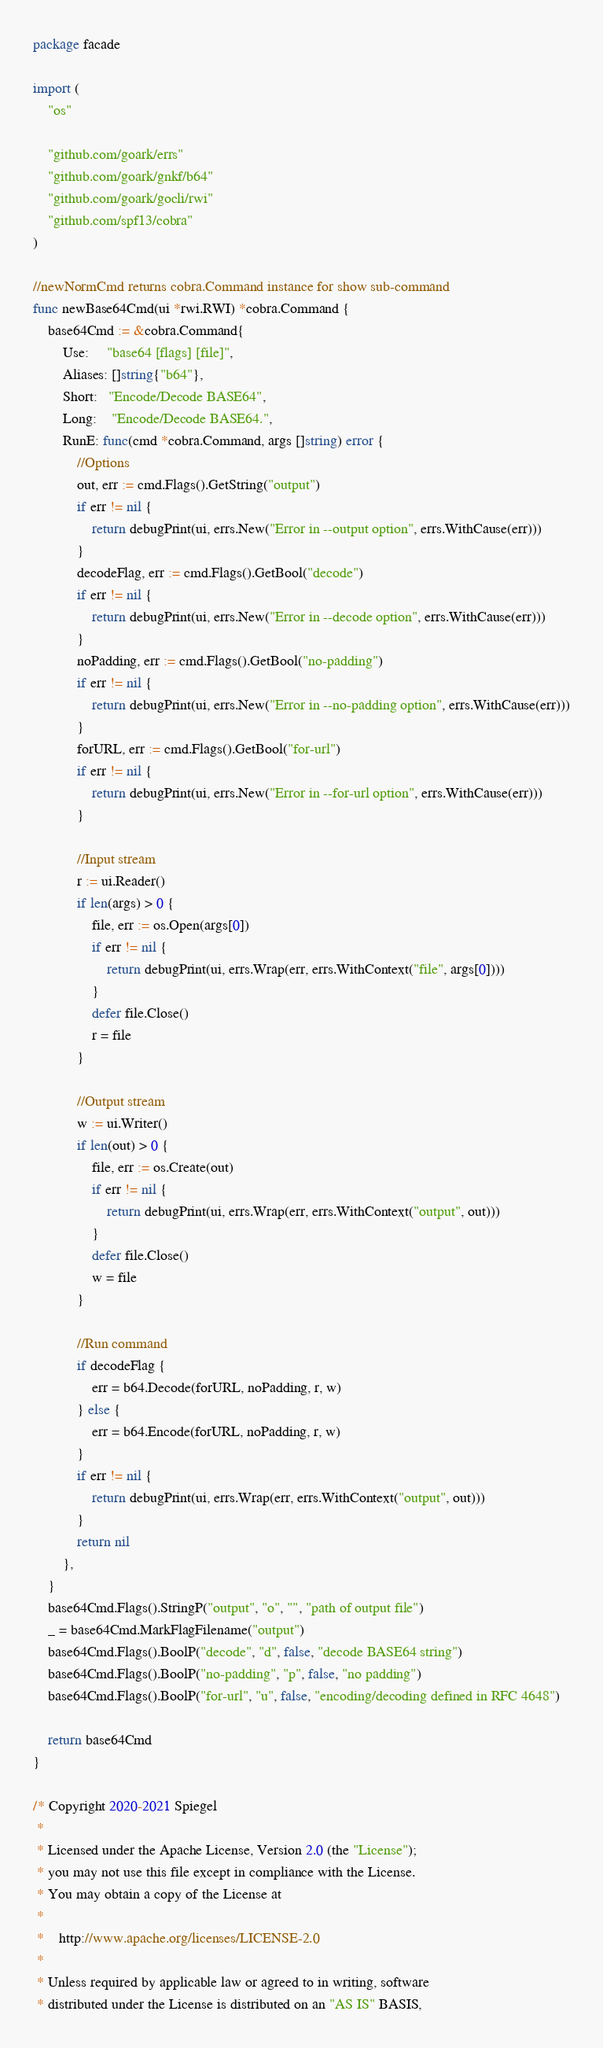Convert code to text. <code><loc_0><loc_0><loc_500><loc_500><_Go_>package facade

import (
	"os"

	"github.com/goark/errs"
	"github.com/goark/gnkf/b64"
	"github.com/goark/gocli/rwi"
	"github.com/spf13/cobra"
)

//newNormCmd returns cobra.Command instance for show sub-command
func newBase64Cmd(ui *rwi.RWI) *cobra.Command {
	base64Cmd := &cobra.Command{
		Use:     "base64 [flags] [file]",
		Aliases: []string{"b64"},
		Short:   "Encode/Decode BASE64",
		Long:    "Encode/Decode BASE64.",
		RunE: func(cmd *cobra.Command, args []string) error {
			//Options
			out, err := cmd.Flags().GetString("output")
			if err != nil {
				return debugPrint(ui, errs.New("Error in --output option", errs.WithCause(err)))
			}
			decodeFlag, err := cmd.Flags().GetBool("decode")
			if err != nil {
				return debugPrint(ui, errs.New("Error in --decode option", errs.WithCause(err)))
			}
			noPadding, err := cmd.Flags().GetBool("no-padding")
			if err != nil {
				return debugPrint(ui, errs.New("Error in --no-padding option", errs.WithCause(err)))
			}
			forURL, err := cmd.Flags().GetBool("for-url")
			if err != nil {
				return debugPrint(ui, errs.New("Error in --for-url option", errs.WithCause(err)))
			}

			//Input stream
			r := ui.Reader()
			if len(args) > 0 {
				file, err := os.Open(args[0])
				if err != nil {
					return debugPrint(ui, errs.Wrap(err, errs.WithContext("file", args[0])))
				}
				defer file.Close()
				r = file
			}

			//Output stream
			w := ui.Writer()
			if len(out) > 0 {
				file, err := os.Create(out)
				if err != nil {
					return debugPrint(ui, errs.Wrap(err, errs.WithContext("output", out)))
				}
				defer file.Close()
				w = file
			}

			//Run command
			if decodeFlag {
				err = b64.Decode(forURL, noPadding, r, w)
			} else {
				err = b64.Encode(forURL, noPadding, r, w)
			}
			if err != nil {
				return debugPrint(ui, errs.Wrap(err, errs.WithContext("output", out)))
			}
			return nil
		},
	}
	base64Cmd.Flags().StringP("output", "o", "", "path of output file")
	_ = base64Cmd.MarkFlagFilename("output")
	base64Cmd.Flags().BoolP("decode", "d", false, "decode BASE64 string")
	base64Cmd.Flags().BoolP("no-padding", "p", false, "no padding")
	base64Cmd.Flags().BoolP("for-url", "u", false, "encoding/decoding defined in RFC 4648")

	return base64Cmd
}

/* Copyright 2020-2021 Spiegel
 *
 * Licensed under the Apache License, Version 2.0 (the "License");
 * you may not use this file except in compliance with the License.
 * You may obtain a copy of the License at
 *
 * 	http://www.apache.org/licenses/LICENSE-2.0
 *
 * Unless required by applicable law or agreed to in writing, software
 * distributed under the License is distributed on an "AS IS" BASIS,</code> 